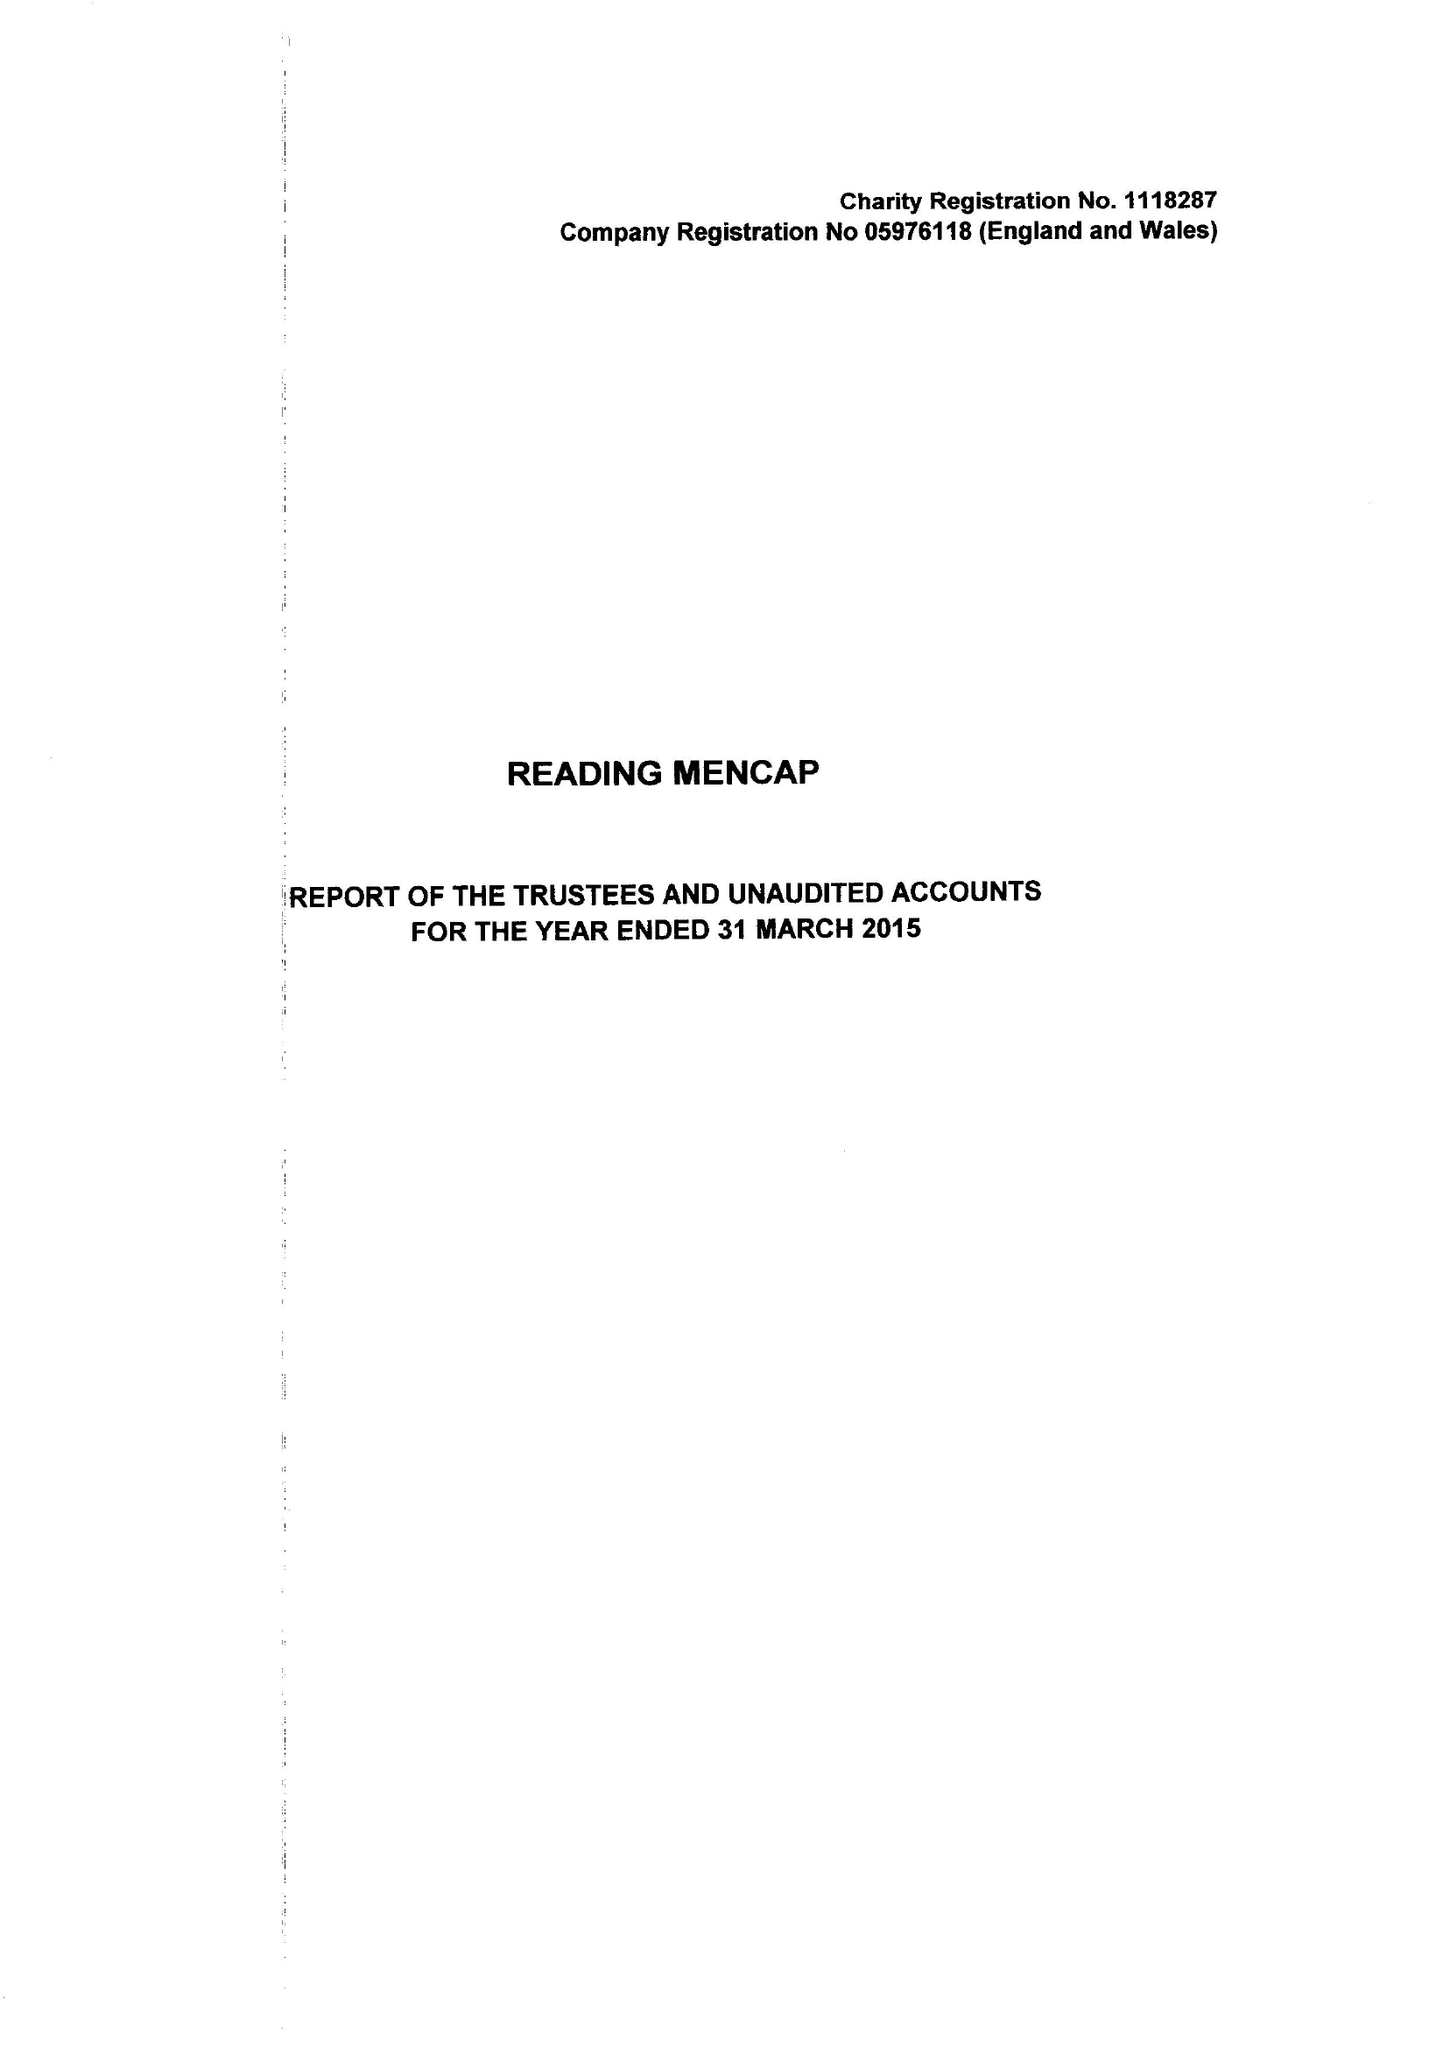What is the value for the spending_annually_in_british_pounds?
Answer the question using a single word or phrase. 394636.00 